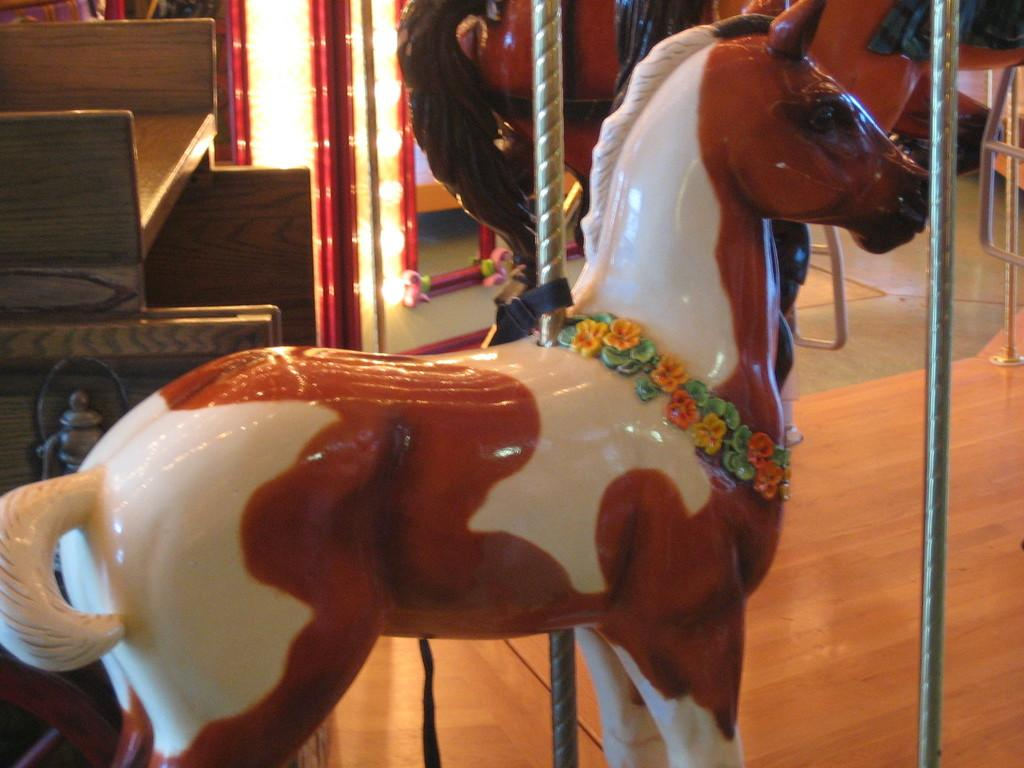What type of animals can be seen in the image? There are carousel horses in the image. What material are the rods in the image made of? The metal rods in the image are made of metal. What type of furniture is present in the image? There is a table in the image. Can you tell me how much milk is being poured into the sink in the image? There is no sink or milk present in the image. How many deer can be seen grazing near the carousel horses in the image? There are no deer present in the image; it only features carousel horses, metal rods, and a table. 